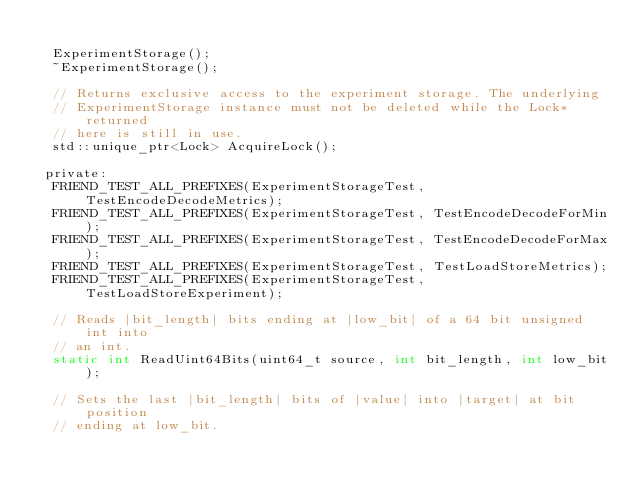<code> <loc_0><loc_0><loc_500><loc_500><_C_>
  ExperimentStorage();
  ~ExperimentStorage();

  // Returns exclusive access to the experiment storage. The underlying
  // ExperimentStorage instance must not be deleted while the Lock* returned
  // here is still in use.
  std::unique_ptr<Lock> AcquireLock();

 private:
  FRIEND_TEST_ALL_PREFIXES(ExperimentStorageTest, TestEncodeDecodeMetrics);
  FRIEND_TEST_ALL_PREFIXES(ExperimentStorageTest, TestEncodeDecodeForMin);
  FRIEND_TEST_ALL_PREFIXES(ExperimentStorageTest, TestEncodeDecodeForMax);
  FRIEND_TEST_ALL_PREFIXES(ExperimentStorageTest, TestLoadStoreMetrics);
  FRIEND_TEST_ALL_PREFIXES(ExperimentStorageTest, TestLoadStoreExperiment);

  // Reads |bit_length| bits ending at |low_bit| of a 64 bit unsigned int into
  // an int.
  static int ReadUint64Bits(uint64_t source, int bit_length, int low_bit);

  // Sets the last |bit_length| bits of |value| into |target| at bit position
  // ending at low_bit.</code> 